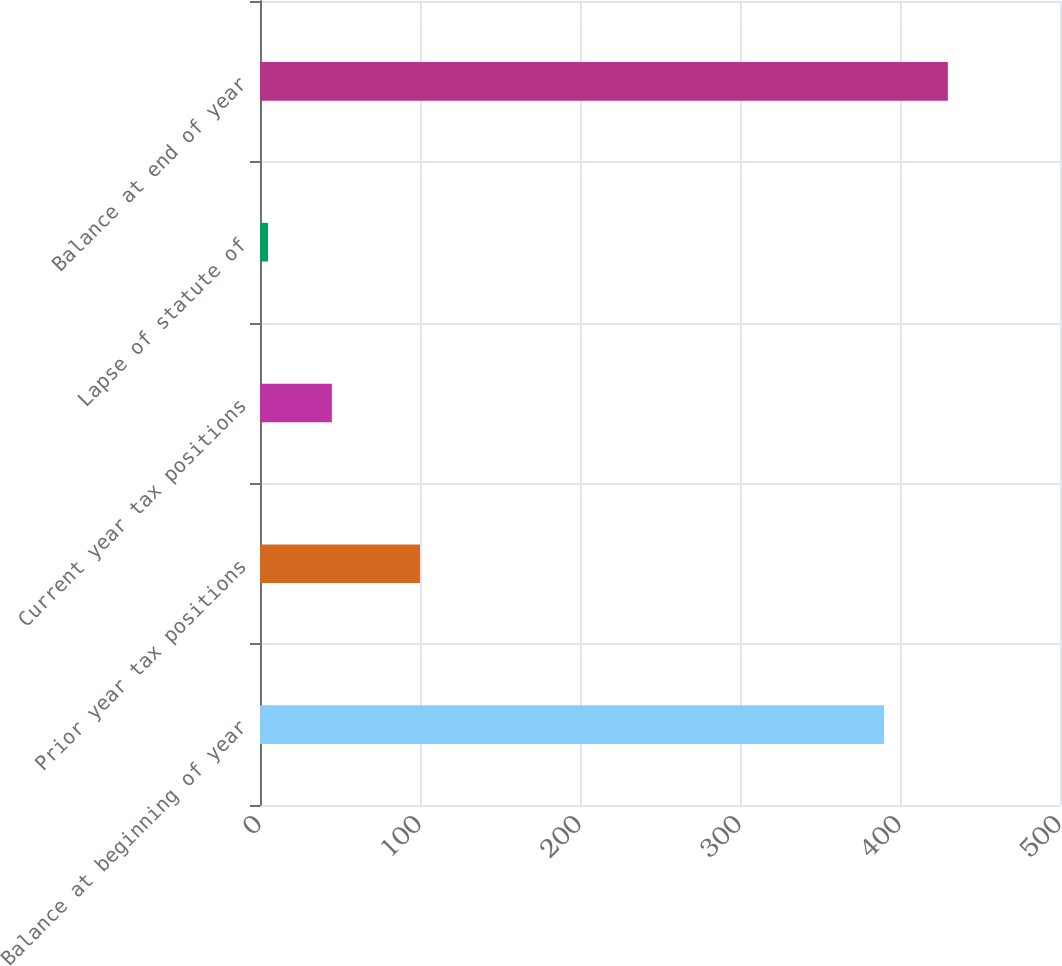Convert chart to OTSL. <chart><loc_0><loc_0><loc_500><loc_500><bar_chart><fcel>Balance at beginning of year<fcel>Prior year tax positions<fcel>Current year tax positions<fcel>Lapse of statute of<fcel>Balance at end of year<nl><fcel>390<fcel>100<fcel>44.9<fcel>5<fcel>429.9<nl></chart> 